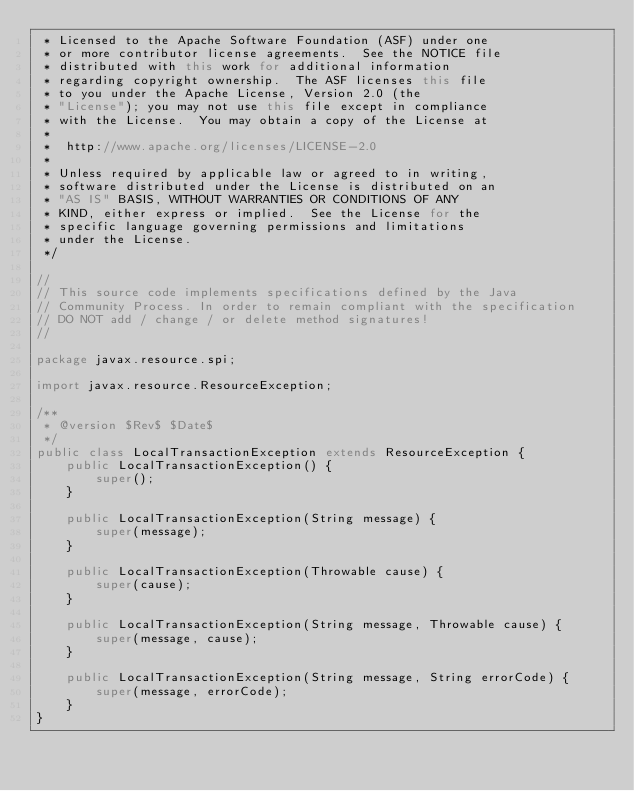<code> <loc_0><loc_0><loc_500><loc_500><_Java_> * Licensed to the Apache Software Foundation (ASF) under one
 * or more contributor license agreements.  See the NOTICE file
 * distributed with this work for additional information
 * regarding copyright ownership.  The ASF licenses this file
 * to you under the Apache License, Version 2.0 (the
 * "License"); you may not use this file except in compliance
 * with the License.  You may obtain a copy of the License at
 *
 *  http://www.apache.org/licenses/LICENSE-2.0
 *
 * Unless required by applicable law or agreed to in writing,
 * software distributed under the License is distributed on an
 * "AS IS" BASIS, WITHOUT WARRANTIES OR CONDITIONS OF ANY
 * KIND, either express or implied.  See the License for the
 * specific language governing permissions and limitations
 * under the License.
 */

//
// This source code implements specifications defined by the Java
// Community Process. In order to remain compliant with the specification
// DO NOT add / change / or delete method signatures!
//

package javax.resource.spi;

import javax.resource.ResourceException;

/**
 * @version $Rev$ $Date$
 */
public class LocalTransactionException extends ResourceException {
    public LocalTransactionException() {
        super();
    }

    public LocalTransactionException(String message) {
        super(message);
    }

    public LocalTransactionException(Throwable cause) {
        super(cause);
    }

    public LocalTransactionException(String message, Throwable cause) {
        super(message, cause);
    }

    public LocalTransactionException(String message, String errorCode) {
        super(message, errorCode);
    }
}
</code> 